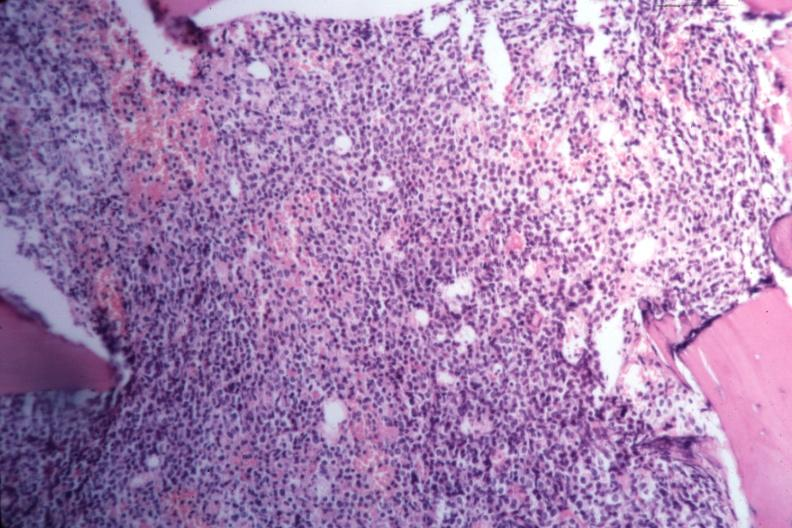s rocky mountain present?
Answer the question using a single word or phrase. No 